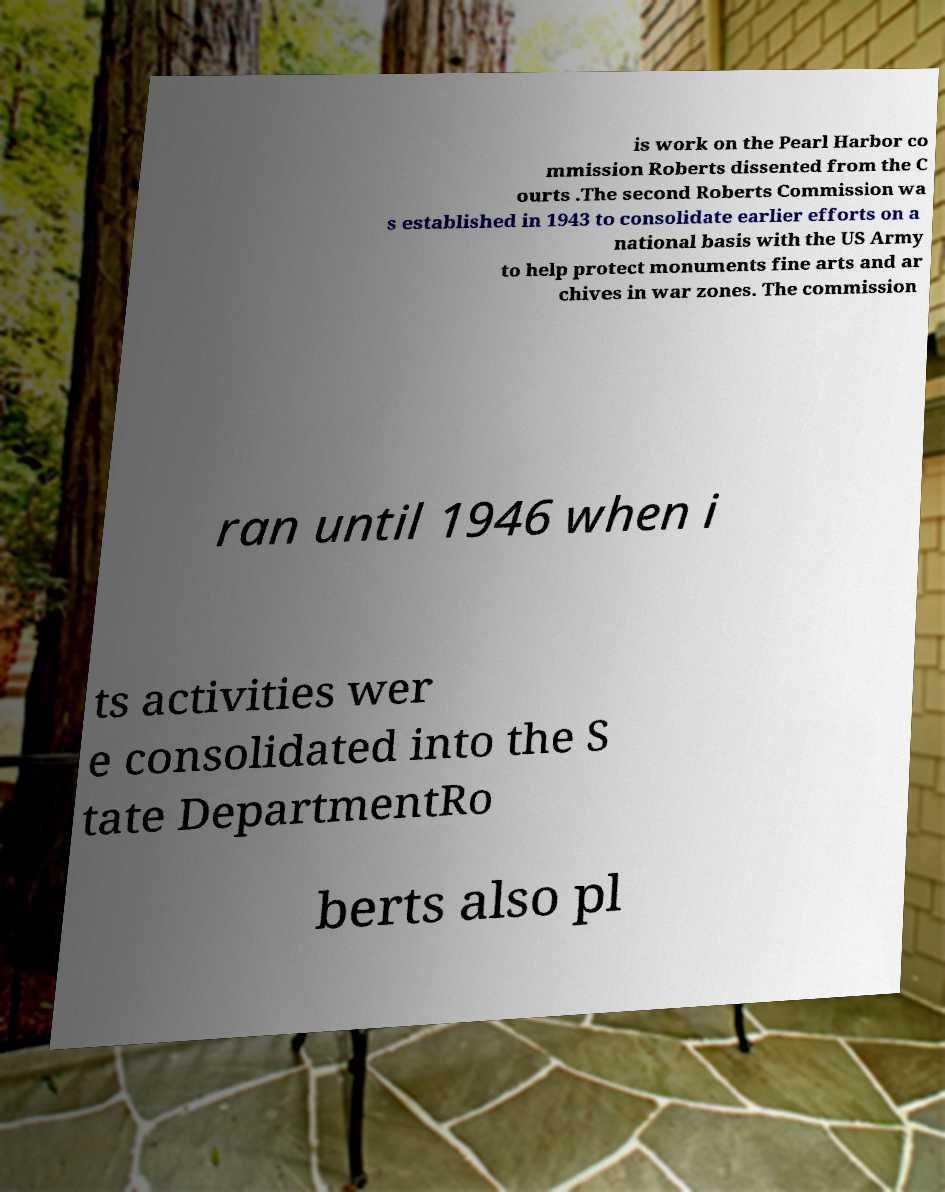What messages or text are displayed in this image? I need them in a readable, typed format. is work on the Pearl Harbor co mmission Roberts dissented from the C ourts .The second Roberts Commission wa s established in 1943 to consolidate earlier efforts on a national basis with the US Army to help protect monuments fine arts and ar chives in war zones. The commission ran until 1946 when i ts activities wer e consolidated into the S tate DepartmentRo berts also pl 